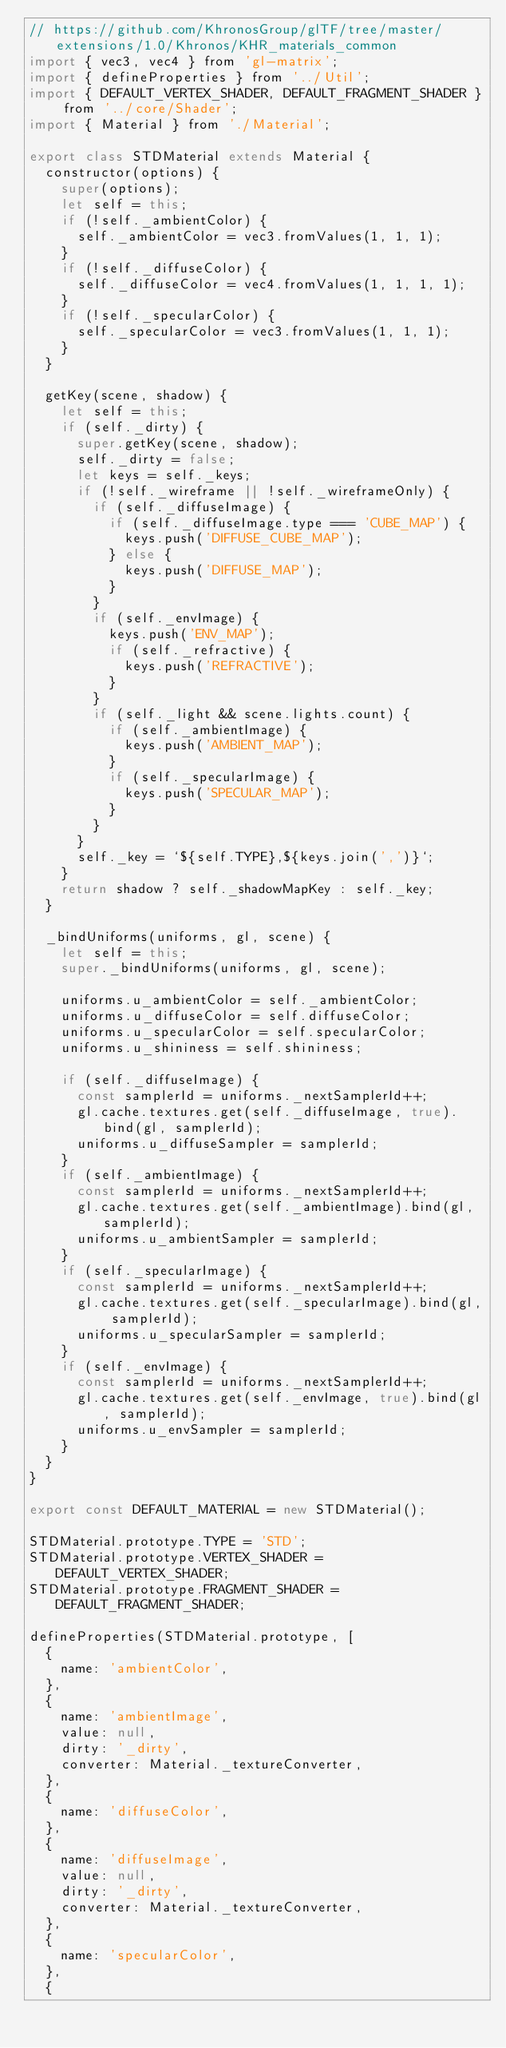Convert code to text. <code><loc_0><loc_0><loc_500><loc_500><_JavaScript_>// https://github.com/KhronosGroup/glTF/tree/master/extensions/1.0/Khronos/KHR_materials_common
import { vec3, vec4 } from 'gl-matrix';
import { defineProperties } from '../Util';
import { DEFAULT_VERTEX_SHADER, DEFAULT_FRAGMENT_SHADER } from '../core/Shader';
import { Material } from './Material';

export class STDMaterial extends Material {
  constructor(options) {
    super(options);
    let self = this;
    if (!self._ambientColor) {
      self._ambientColor = vec3.fromValues(1, 1, 1);
    }
    if (!self._diffuseColor) {
      self._diffuseColor = vec4.fromValues(1, 1, 1, 1);
    }
    if (!self._specularColor) {
      self._specularColor = vec3.fromValues(1, 1, 1);
    }
  }

  getKey(scene, shadow) {
    let self = this;
    if (self._dirty) {
      super.getKey(scene, shadow);
      self._dirty = false;
      let keys = self._keys;
      if (!self._wireframe || !self._wireframeOnly) {
        if (self._diffuseImage) {
          if (self._diffuseImage.type === 'CUBE_MAP') {
            keys.push('DIFFUSE_CUBE_MAP');
          } else {
            keys.push('DIFFUSE_MAP');
          }
        }
        if (self._envImage) {
          keys.push('ENV_MAP');
          if (self._refractive) {
            keys.push('REFRACTIVE');
          }
        }
        if (self._light && scene.lights.count) {
          if (self._ambientImage) {
            keys.push('AMBIENT_MAP');
          }
          if (self._specularImage) {
            keys.push('SPECULAR_MAP');
          }
        }
      }
      self._key = `${self.TYPE},${keys.join(',')}`;
    }
    return shadow ? self._shadowMapKey : self._key;
  }

  _bindUniforms(uniforms, gl, scene) {
    let self = this;
    super._bindUniforms(uniforms, gl, scene);

    uniforms.u_ambientColor = self._ambientColor;
    uniforms.u_diffuseColor = self.diffuseColor;
    uniforms.u_specularColor = self.specularColor;
    uniforms.u_shininess = self.shininess;

    if (self._diffuseImage) {
      const samplerId = uniforms._nextSamplerId++;
      gl.cache.textures.get(self._diffuseImage, true).bind(gl, samplerId);
      uniforms.u_diffuseSampler = samplerId;
    }
    if (self._ambientImage) {
      const samplerId = uniforms._nextSamplerId++;
      gl.cache.textures.get(self._ambientImage).bind(gl, samplerId);
      uniforms.u_ambientSampler = samplerId;
    }
    if (self._specularImage) {
      const samplerId = uniforms._nextSamplerId++;
      gl.cache.textures.get(self._specularImage).bind(gl, samplerId);
      uniforms.u_specularSampler = samplerId;
    }
    if (self._envImage) {
      const samplerId = uniforms._nextSamplerId++;
      gl.cache.textures.get(self._envImage, true).bind(gl, samplerId);
      uniforms.u_envSampler = samplerId;
    }
  }
}

export const DEFAULT_MATERIAL = new STDMaterial();

STDMaterial.prototype.TYPE = 'STD';
STDMaterial.prototype.VERTEX_SHADER = DEFAULT_VERTEX_SHADER;
STDMaterial.prototype.FRAGMENT_SHADER = DEFAULT_FRAGMENT_SHADER;

defineProperties(STDMaterial.prototype, [
  {
    name: 'ambientColor',
  },
  {
    name: 'ambientImage',
    value: null,
    dirty: '_dirty',
    converter: Material._textureConverter,
  },
  {
    name: 'diffuseColor',
  },
  {
    name: 'diffuseImage',
    value: null,
    dirty: '_dirty',
    converter: Material._textureConverter,
  },
  {
    name: 'specularColor',
  },
  {</code> 